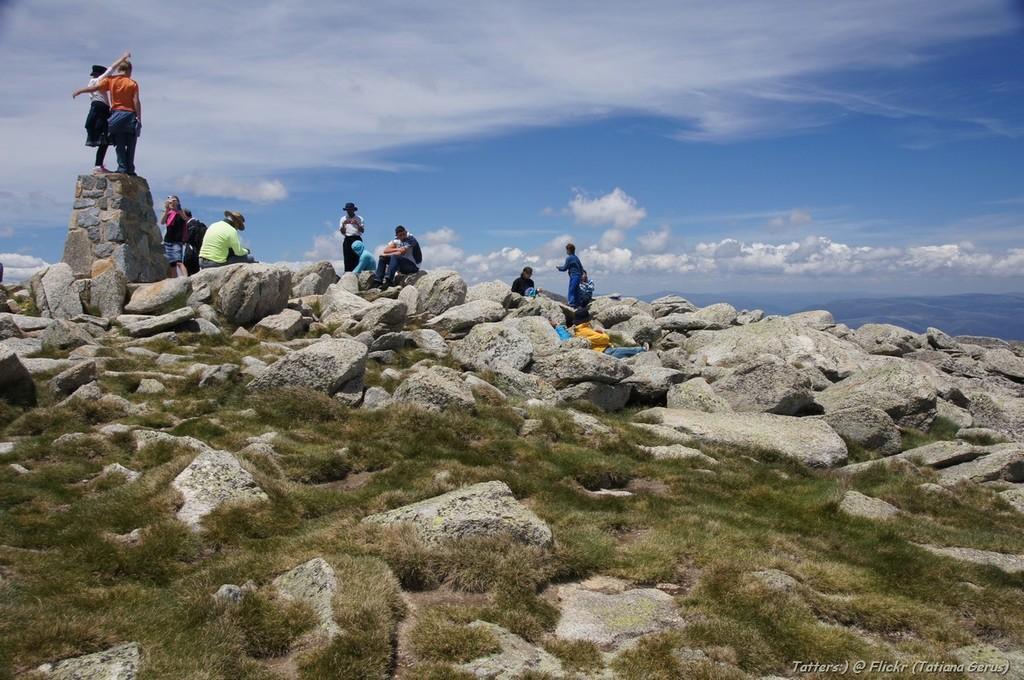How would you summarize this image in a sentence or two? This picture is clicked outside the city. In the foreground we can see the rocks and the green grass. In the center there are two person standing on the rock and we can see the group of people. In the background there is a sky with some clouds. 